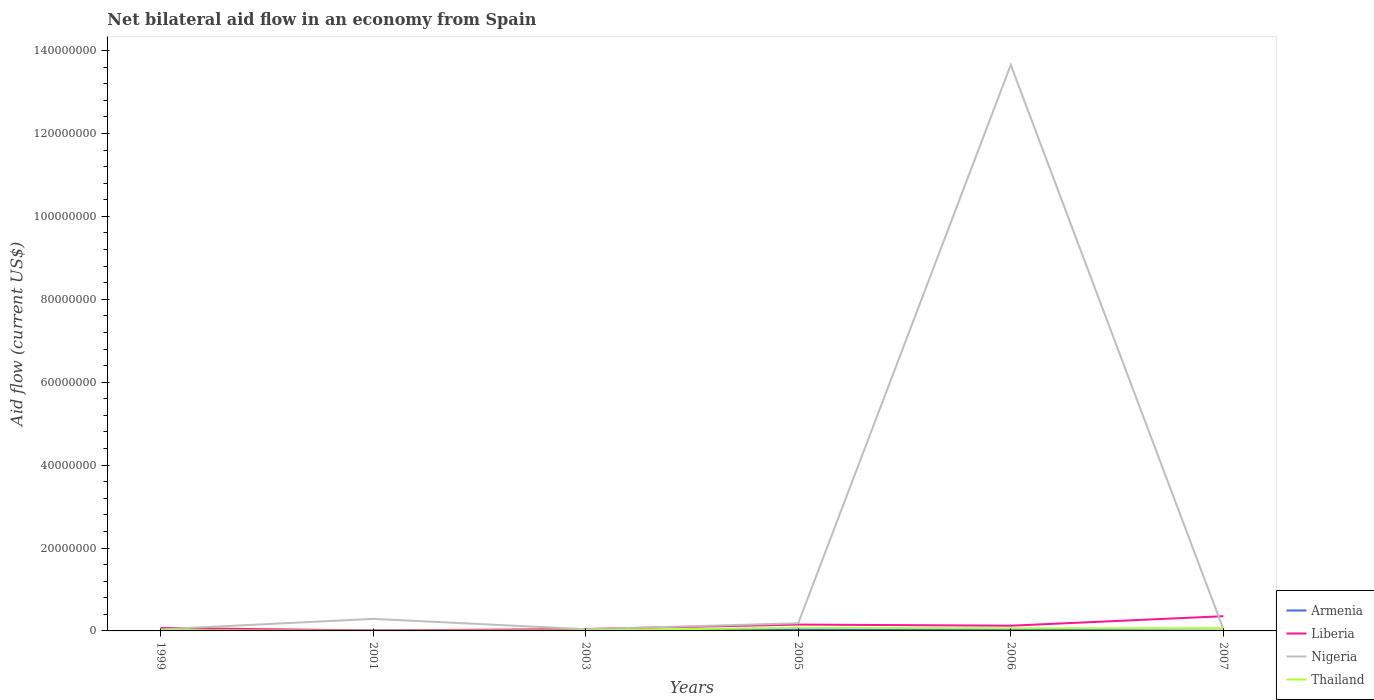Across all years, what is the maximum net bilateral aid flow in Thailand?
Offer a terse response. 5.00e+04. What is the total net bilateral aid flow in Armenia in the graph?
Your response must be concise. 3.00e+04. What is the difference between the highest and the second highest net bilateral aid flow in Thailand?
Your answer should be very brief. 7.10e+05. Is the net bilateral aid flow in Thailand strictly greater than the net bilateral aid flow in Armenia over the years?
Keep it short and to the point. No. What is the difference between two consecutive major ticks on the Y-axis?
Give a very brief answer. 2.00e+07. Does the graph contain grids?
Offer a terse response. No. Where does the legend appear in the graph?
Your answer should be compact. Bottom right. How are the legend labels stacked?
Your answer should be compact. Vertical. What is the title of the graph?
Offer a terse response. Net bilateral aid flow in an economy from Spain. Does "Somalia" appear as one of the legend labels in the graph?
Make the answer very short. No. What is the label or title of the X-axis?
Keep it short and to the point. Years. What is the label or title of the Y-axis?
Your response must be concise. Aid flow (current US$). What is the Aid flow (current US$) of Liberia in 1999?
Ensure brevity in your answer.  7.10e+05. What is the Aid flow (current US$) of Armenia in 2001?
Make the answer very short. 1.10e+05. What is the Aid flow (current US$) of Nigeria in 2001?
Offer a very short reply. 2.91e+06. What is the Aid flow (current US$) in Thailand in 2001?
Offer a terse response. 5.00e+04. What is the Aid flow (current US$) of Liberia in 2003?
Your answer should be compact. 4.60e+05. What is the Aid flow (current US$) in Nigeria in 2003?
Your answer should be very brief. 4.10e+05. What is the Aid flow (current US$) of Thailand in 2003?
Provide a succinct answer. 1.20e+05. What is the Aid flow (current US$) in Liberia in 2005?
Your answer should be compact. 1.53e+06. What is the Aid flow (current US$) in Nigeria in 2005?
Offer a terse response. 1.85e+06. What is the Aid flow (current US$) of Thailand in 2005?
Give a very brief answer. 7.60e+05. What is the Aid flow (current US$) in Liberia in 2006?
Your response must be concise. 1.26e+06. What is the Aid flow (current US$) in Nigeria in 2006?
Give a very brief answer. 1.37e+08. What is the Aid flow (current US$) in Thailand in 2006?
Your answer should be very brief. 6.20e+05. What is the Aid flow (current US$) in Armenia in 2007?
Your response must be concise. 5.00e+04. What is the Aid flow (current US$) in Liberia in 2007?
Offer a terse response. 3.55e+06. What is the Aid flow (current US$) in Nigeria in 2007?
Your answer should be very brief. 4.70e+05. What is the Aid flow (current US$) in Thailand in 2007?
Your answer should be very brief. 6.60e+05. Across all years, what is the maximum Aid flow (current US$) in Armenia?
Ensure brevity in your answer.  3.90e+05. Across all years, what is the maximum Aid flow (current US$) of Liberia?
Offer a terse response. 3.55e+06. Across all years, what is the maximum Aid flow (current US$) of Nigeria?
Your response must be concise. 1.37e+08. Across all years, what is the maximum Aid flow (current US$) of Thailand?
Your answer should be compact. 7.60e+05. Across all years, what is the minimum Aid flow (current US$) of Armenia?
Give a very brief answer. 5.00e+04. Across all years, what is the minimum Aid flow (current US$) of Liberia?
Your answer should be compact. 1.10e+05. Across all years, what is the minimum Aid flow (current US$) of Nigeria?
Provide a short and direct response. 3.80e+05. What is the total Aid flow (current US$) in Armenia in the graph?
Your response must be concise. 9.80e+05. What is the total Aid flow (current US$) in Liberia in the graph?
Your answer should be compact. 7.62e+06. What is the total Aid flow (current US$) of Nigeria in the graph?
Your answer should be compact. 1.43e+08. What is the total Aid flow (current US$) of Thailand in the graph?
Keep it short and to the point. 2.38e+06. What is the difference between the Aid flow (current US$) in Armenia in 1999 and that in 2001?
Offer a terse response. -5.00e+04. What is the difference between the Aid flow (current US$) of Nigeria in 1999 and that in 2001?
Give a very brief answer. -2.53e+06. What is the difference between the Aid flow (current US$) of Armenia in 1999 and that in 2003?
Keep it short and to the point. -2.00e+04. What is the difference between the Aid flow (current US$) of Liberia in 1999 and that in 2003?
Offer a very short reply. 2.50e+05. What is the difference between the Aid flow (current US$) of Thailand in 1999 and that in 2003?
Give a very brief answer. 5.00e+04. What is the difference between the Aid flow (current US$) in Armenia in 1999 and that in 2005?
Keep it short and to the point. -3.30e+05. What is the difference between the Aid flow (current US$) in Liberia in 1999 and that in 2005?
Provide a succinct answer. -8.20e+05. What is the difference between the Aid flow (current US$) in Nigeria in 1999 and that in 2005?
Give a very brief answer. -1.47e+06. What is the difference between the Aid flow (current US$) of Thailand in 1999 and that in 2005?
Ensure brevity in your answer.  -5.90e+05. What is the difference between the Aid flow (current US$) of Liberia in 1999 and that in 2006?
Offer a very short reply. -5.50e+05. What is the difference between the Aid flow (current US$) in Nigeria in 1999 and that in 2006?
Provide a succinct answer. -1.36e+08. What is the difference between the Aid flow (current US$) of Thailand in 1999 and that in 2006?
Ensure brevity in your answer.  -4.50e+05. What is the difference between the Aid flow (current US$) in Armenia in 1999 and that in 2007?
Keep it short and to the point. 10000. What is the difference between the Aid flow (current US$) of Liberia in 1999 and that in 2007?
Make the answer very short. -2.84e+06. What is the difference between the Aid flow (current US$) of Nigeria in 1999 and that in 2007?
Provide a succinct answer. -9.00e+04. What is the difference between the Aid flow (current US$) in Thailand in 1999 and that in 2007?
Keep it short and to the point. -4.90e+05. What is the difference between the Aid flow (current US$) of Armenia in 2001 and that in 2003?
Provide a short and direct response. 3.00e+04. What is the difference between the Aid flow (current US$) of Liberia in 2001 and that in 2003?
Make the answer very short. -3.50e+05. What is the difference between the Aid flow (current US$) of Nigeria in 2001 and that in 2003?
Keep it short and to the point. 2.50e+06. What is the difference between the Aid flow (current US$) of Armenia in 2001 and that in 2005?
Give a very brief answer. -2.80e+05. What is the difference between the Aid flow (current US$) in Liberia in 2001 and that in 2005?
Keep it short and to the point. -1.42e+06. What is the difference between the Aid flow (current US$) in Nigeria in 2001 and that in 2005?
Make the answer very short. 1.06e+06. What is the difference between the Aid flow (current US$) of Thailand in 2001 and that in 2005?
Provide a short and direct response. -7.10e+05. What is the difference between the Aid flow (current US$) of Armenia in 2001 and that in 2006?
Make the answer very short. -1.80e+05. What is the difference between the Aid flow (current US$) of Liberia in 2001 and that in 2006?
Ensure brevity in your answer.  -1.15e+06. What is the difference between the Aid flow (current US$) of Nigeria in 2001 and that in 2006?
Your response must be concise. -1.34e+08. What is the difference between the Aid flow (current US$) of Thailand in 2001 and that in 2006?
Your response must be concise. -5.70e+05. What is the difference between the Aid flow (current US$) in Armenia in 2001 and that in 2007?
Ensure brevity in your answer.  6.00e+04. What is the difference between the Aid flow (current US$) of Liberia in 2001 and that in 2007?
Provide a succinct answer. -3.44e+06. What is the difference between the Aid flow (current US$) of Nigeria in 2001 and that in 2007?
Provide a succinct answer. 2.44e+06. What is the difference between the Aid flow (current US$) of Thailand in 2001 and that in 2007?
Make the answer very short. -6.10e+05. What is the difference between the Aid flow (current US$) of Armenia in 2003 and that in 2005?
Offer a very short reply. -3.10e+05. What is the difference between the Aid flow (current US$) of Liberia in 2003 and that in 2005?
Your response must be concise. -1.07e+06. What is the difference between the Aid flow (current US$) of Nigeria in 2003 and that in 2005?
Provide a succinct answer. -1.44e+06. What is the difference between the Aid flow (current US$) of Thailand in 2003 and that in 2005?
Offer a terse response. -6.40e+05. What is the difference between the Aid flow (current US$) of Liberia in 2003 and that in 2006?
Offer a very short reply. -8.00e+05. What is the difference between the Aid flow (current US$) in Nigeria in 2003 and that in 2006?
Offer a very short reply. -1.36e+08. What is the difference between the Aid flow (current US$) of Thailand in 2003 and that in 2006?
Your answer should be compact. -5.00e+05. What is the difference between the Aid flow (current US$) of Liberia in 2003 and that in 2007?
Keep it short and to the point. -3.09e+06. What is the difference between the Aid flow (current US$) of Nigeria in 2003 and that in 2007?
Your answer should be compact. -6.00e+04. What is the difference between the Aid flow (current US$) of Thailand in 2003 and that in 2007?
Your answer should be compact. -5.40e+05. What is the difference between the Aid flow (current US$) in Liberia in 2005 and that in 2006?
Your response must be concise. 2.70e+05. What is the difference between the Aid flow (current US$) of Nigeria in 2005 and that in 2006?
Your answer should be compact. -1.35e+08. What is the difference between the Aid flow (current US$) in Thailand in 2005 and that in 2006?
Your answer should be very brief. 1.40e+05. What is the difference between the Aid flow (current US$) of Armenia in 2005 and that in 2007?
Give a very brief answer. 3.40e+05. What is the difference between the Aid flow (current US$) of Liberia in 2005 and that in 2007?
Ensure brevity in your answer.  -2.02e+06. What is the difference between the Aid flow (current US$) in Nigeria in 2005 and that in 2007?
Give a very brief answer. 1.38e+06. What is the difference between the Aid flow (current US$) in Liberia in 2006 and that in 2007?
Offer a terse response. -2.29e+06. What is the difference between the Aid flow (current US$) in Nigeria in 2006 and that in 2007?
Make the answer very short. 1.36e+08. What is the difference between the Aid flow (current US$) of Thailand in 2006 and that in 2007?
Make the answer very short. -4.00e+04. What is the difference between the Aid flow (current US$) of Armenia in 1999 and the Aid flow (current US$) of Nigeria in 2001?
Provide a short and direct response. -2.85e+06. What is the difference between the Aid flow (current US$) of Armenia in 1999 and the Aid flow (current US$) of Thailand in 2001?
Your response must be concise. 10000. What is the difference between the Aid flow (current US$) of Liberia in 1999 and the Aid flow (current US$) of Nigeria in 2001?
Make the answer very short. -2.20e+06. What is the difference between the Aid flow (current US$) in Armenia in 1999 and the Aid flow (current US$) in Liberia in 2003?
Your answer should be compact. -4.00e+05. What is the difference between the Aid flow (current US$) of Armenia in 1999 and the Aid flow (current US$) of Nigeria in 2003?
Provide a succinct answer. -3.50e+05. What is the difference between the Aid flow (current US$) in Armenia in 1999 and the Aid flow (current US$) in Thailand in 2003?
Provide a short and direct response. -6.00e+04. What is the difference between the Aid flow (current US$) of Liberia in 1999 and the Aid flow (current US$) of Thailand in 2003?
Your answer should be very brief. 5.90e+05. What is the difference between the Aid flow (current US$) of Nigeria in 1999 and the Aid flow (current US$) of Thailand in 2003?
Provide a succinct answer. 2.60e+05. What is the difference between the Aid flow (current US$) of Armenia in 1999 and the Aid flow (current US$) of Liberia in 2005?
Provide a short and direct response. -1.47e+06. What is the difference between the Aid flow (current US$) of Armenia in 1999 and the Aid flow (current US$) of Nigeria in 2005?
Provide a succinct answer. -1.79e+06. What is the difference between the Aid flow (current US$) of Armenia in 1999 and the Aid flow (current US$) of Thailand in 2005?
Offer a very short reply. -7.00e+05. What is the difference between the Aid flow (current US$) in Liberia in 1999 and the Aid flow (current US$) in Nigeria in 2005?
Your answer should be compact. -1.14e+06. What is the difference between the Aid flow (current US$) in Nigeria in 1999 and the Aid flow (current US$) in Thailand in 2005?
Offer a terse response. -3.80e+05. What is the difference between the Aid flow (current US$) in Armenia in 1999 and the Aid flow (current US$) in Liberia in 2006?
Give a very brief answer. -1.20e+06. What is the difference between the Aid flow (current US$) in Armenia in 1999 and the Aid flow (current US$) in Nigeria in 2006?
Give a very brief answer. -1.36e+08. What is the difference between the Aid flow (current US$) of Armenia in 1999 and the Aid flow (current US$) of Thailand in 2006?
Make the answer very short. -5.60e+05. What is the difference between the Aid flow (current US$) in Liberia in 1999 and the Aid flow (current US$) in Nigeria in 2006?
Your answer should be compact. -1.36e+08. What is the difference between the Aid flow (current US$) of Armenia in 1999 and the Aid flow (current US$) of Liberia in 2007?
Offer a very short reply. -3.49e+06. What is the difference between the Aid flow (current US$) of Armenia in 1999 and the Aid flow (current US$) of Nigeria in 2007?
Make the answer very short. -4.10e+05. What is the difference between the Aid flow (current US$) of Armenia in 1999 and the Aid flow (current US$) of Thailand in 2007?
Ensure brevity in your answer.  -6.00e+05. What is the difference between the Aid flow (current US$) in Liberia in 1999 and the Aid flow (current US$) in Nigeria in 2007?
Offer a very short reply. 2.40e+05. What is the difference between the Aid flow (current US$) of Liberia in 1999 and the Aid flow (current US$) of Thailand in 2007?
Your response must be concise. 5.00e+04. What is the difference between the Aid flow (current US$) of Nigeria in 1999 and the Aid flow (current US$) of Thailand in 2007?
Your answer should be compact. -2.80e+05. What is the difference between the Aid flow (current US$) in Armenia in 2001 and the Aid flow (current US$) in Liberia in 2003?
Your response must be concise. -3.50e+05. What is the difference between the Aid flow (current US$) in Armenia in 2001 and the Aid flow (current US$) in Thailand in 2003?
Give a very brief answer. -10000. What is the difference between the Aid flow (current US$) of Liberia in 2001 and the Aid flow (current US$) of Nigeria in 2003?
Your response must be concise. -3.00e+05. What is the difference between the Aid flow (current US$) of Nigeria in 2001 and the Aid flow (current US$) of Thailand in 2003?
Offer a terse response. 2.79e+06. What is the difference between the Aid flow (current US$) of Armenia in 2001 and the Aid flow (current US$) of Liberia in 2005?
Your answer should be compact. -1.42e+06. What is the difference between the Aid flow (current US$) of Armenia in 2001 and the Aid flow (current US$) of Nigeria in 2005?
Provide a short and direct response. -1.74e+06. What is the difference between the Aid flow (current US$) in Armenia in 2001 and the Aid flow (current US$) in Thailand in 2005?
Your answer should be compact. -6.50e+05. What is the difference between the Aid flow (current US$) of Liberia in 2001 and the Aid flow (current US$) of Nigeria in 2005?
Provide a short and direct response. -1.74e+06. What is the difference between the Aid flow (current US$) of Liberia in 2001 and the Aid flow (current US$) of Thailand in 2005?
Your response must be concise. -6.50e+05. What is the difference between the Aid flow (current US$) of Nigeria in 2001 and the Aid flow (current US$) of Thailand in 2005?
Give a very brief answer. 2.15e+06. What is the difference between the Aid flow (current US$) of Armenia in 2001 and the Aid flow (current US$) of Liberia in 2006?
Provide a succinct answer. -1.15e+06. What is the difference between the Aid flow (current US$) in Armenia in 2001 and the Aid flow (current US$) in Nigeria in 2006?
Ensure brevity in your answer.  -1.36e+08. What is the difference between the Aid flow (current US$) in Armenia in 2001 and the Aid flow (current US$) in Thailand in 2006?
Keep it short and to the point. -5.10e+05. What is the difference between the Aid flow (current US$) of Liberia in 2001 and the Aid flow (current US$) of Nigeria in 2006?
Ensure brevity in your answer.  -1.36e+08. What is the difference between the Aid flow (current US$) in Liberia in 2001 and the Aid flow (current US$) in Thailand in 2006?
Give a very brief answer. -5.10e+05. What is the difference between the Aid flow (current US$) of Nigeria in 2001 and the Aid flow (current US$) of Thailand in 2006?
Keep it short and to the point. 2.29e+06. What is the difference between the Aid flow (current US$) of Armenia in 2001 and the Aid flow (current US$) of Liberia in 2007?
Give a very brief answer. -3.44e+06. What is the difference between the Aid flow (current US$) of Armenia in 2001 and the Aid flow (current US$) of Nigeria in 2007?
Give a very brief answer. -3.60e+05. What is the difference between the Aid flow (current US$) in Armenia in 2001 and the Aid flow (current US$) in Thailand in 2007?
Offer a very short reply. -5.50e+05. What is the difference between the Aid flow (current US$) in Liberia in 2001 and the Aid flow (current US$) in Nigeria in 2007?
Provide a short and direct response. -3.60e+05. What is the difference between the Aid flow (current US$) in Liberia in 2001 and the Aid flow (current US$) in Thailand in 2007?
Keep it short and to the point. -5.50e+05. What is the difference between the Aid flow (current US$) in Nigeria in 2001 and the Aid flow (current US$) in Thailand in 2007?
Ensure brevity in your answer.  2.25e+06. What is the difference between the Aid flow (current US$) of Armenia in 2003 and the Aid flow (current US$) of Liberia in 2005?
Your answer should be compact. -1.45e+06. What is the difference between the Aid flow (current US$) in Armenia in 2003 and the Aid flow (current US$) in Nigeria in 2005?
Your answer should be very brief. -1.77e+06. What is the difference between the Aid flow (current US$) in Armenia in 2003 and the Aid flow (current US$) in Thailand in 2005?
Offer a very short reply. -6.80e+05. What is the difference between the Aid flow (current US$) of Liberia in 2003 and the Aid flow (current US$) of Nigeria in 2005?
Offer a terse response. -1.39e+06. What is the difference between the Aid flow (current US$) of Nigeria in 2003 and the Aid flow (current US$) of Thailand in 2005?
Your answer should be compact. -3.50e+05. What is the difference between the Aid flow (current US$) of Armenia in 2003 and the Aid flow (current US$) of Liberia in 2006?
Make the answer very short. -1.18e+06. What is the difference between the Aid flow (current US$) in Armenia in 2003 and the Aid flow (current US$) in Nigeria in 2006?
Ensure brevity in your answer.  -1.36e+08. What is the difference between the Aid flow (current US$) of Armenia in 2003 and the Aid flow (current US$) of Thailand in 2006?
Give a very brief answer. -5.40e+05. What is the difference between the Aid flow (current US$) in Liberia in 2003 and the Aid flow (current US$) in Nigeria in 2006?
Offer a very short reply. -1.36e+08. What is the difference between the Aid flow (current US$) of Armenia in 2003 and the Aid flow (current US$) of Liberia in 2007?
Provide a short and direct response. -3.47e+06. What is the difference between the Aid flow (current US$) of Armenia in 2003 and the Aid flow (current US$) of Nigeria in 2007?
Offer a very short reply. -3.90e+05. What is the difference between the Aid flow (current US$) in Armenia in 2003 and the Aid flow (current US$) in Thailand in 2007?
Your response must be concise. -5.80e+05. What is the difference between the Aid flow (current US$) in Liberia in 2003 and the Aid flow (current US$) in Thailand in 2007?
Keep it short and to the point. -2.00e+05. What is the difference between the Aid flow (current US$) of Armenia in 2005 and the Aid flow (current US$) of Liberia in 2006?
Offer a very short reply. -8.70e+05. What is the difference between the Aid flow (current US$) of Armenia in 2005 and the Aid flow (current US$) of Nigeria in 2006?
Offer a terse response. -1.36e+08. What is the difference between the Aid flow (current US$) in Armenia in 2005 and the Aid flow (current US$) in Thailand in 2006?
Ensure brevity in your answer.  -2.30e+05. What is the difference between the Aid flow (current US$) in Liberia in 2005 and the Aid flow (current US$) in Nigeria in 2006?
Your answer should be very brief. -1.35e+08. What is the difference between the Aid flow (current US$) of Liberia in 2005 and the Aid flow (current US$) of Thailand in 2006?
Ensure brevity in your answer.  9.10e+05. What is the difference between the Aid flow (current US$) of Nigeria in 2005 and the Aid flow (current US$) of Thailand in 2006?
Ensure brevity in your answer.  1.23e+06. What is the difference between the Aid flow (current US$) of Armenia in 2005 and the Aid flow (current US$) of Liberia in 2007?
Offer a very short reply. -3.16e+06. What is the difference between the Aid flow (current US$) of Armenia in 2005 and the Aid flow (current US$) of Thailand in 2007?
Offer a very short reply. -2.70e+05. What is the difference between the Aid flow (current US$) in Liberia in 2005 and the Aid flow (current US$) in Nigeria in 2007?
Make the answer very short. 1.06e+06. What is the difference between the Aid flow (current US$) of Liberia in 2005 and the Aid flow (current US$) of Thailand in 2007?
Offer a terse response. 8.70e+05. What is the difference between the Aid flow (current US$) of Nigeria in 2005 and the Aid flow (current US$) of Thailand in 2007?
Make the answer very short. 1.19e+06. What is the difference between the Aid flow (current US$) of Armenia in 2006 and the Aid flow (current US$) of Liberia in 2007?
Your answer should be very brief. -3.26e+06. What is the difference between the Aid flow (current US$) in Armenia in 2006 and the Aid flow (current US$) in Thailand in 2007?
Your answer should be very brief. -3.70e+05. What is the difference between the Aid flow (current US$) in Liberia in 2006 and the Aid flow (current US$) in Nigeria in 2007?
Provide a succinct answer. 7.90e+05. What is the difference between the Aid flow (current US$) of Nigeria in 2006 and the Aid flow (current US$) of Thailand in 2007?
Provide a succinct answer. 1.36e+08. What is the average Aid flow (current US$) of Armenia per year?
Make the answer very short. 1.63e+05. What is the average Aid flow (current US$) in Liberia per year?
Ensure brevity in your answer.  1.27e+06. What is the average Aid flow (current US$) in Nigeria per year?
Give a very brief answer. 2.38e+07. What is the average Aid flow (current US$) of Thailand per year?
Your answer should be compact. 3.97e+05. In the year 1999, what is the difference between the Aid flow (current US$) of Armenia and Aid flow (current US$) of Liberia?
Provide a succinct answer. -6.50e+05. In the year 1999, what is the difference between the Aid flow (current US$) of Armenia and Aid flow (current US$) of Nigeria?
Ensure brevity in your answer.  -3.20e+05. In the year 1999, what is the difference between the Aid flow (current US$) of Liberia and Aid flow (current US$) of Thailand?
Give a very brief answer. 5.40e+05. In the year 1999, what is the difference between the Aid flow (current US$) of Nigeria and Aid flow (current US$) of Thailand?
Your answer should be compact. 2.10e+05. In the year 2001, what is the difference between the Aid flow (current US$) of Armenia and Aid flow (current US$) of Nigeria?
Make the answer very short. -2.80e+06. In the year 2001, what is the difference between the Aid flow (current US$) of Liberia and Aid flow (current US$) of Nigeria?
Give a very brief answer. -2.80e+06. In the year 2001, what is the difference between the Aid flow (current US$) of Liberia and Aid flow (current US$) of Thailand?
Make the answer very short. 6.00e+04. In the year 2001, what is the difference between the Aid flow (current US$) of Nigeria and Aid flow (current US$) of Thailand?
Your answer should be very brief. 2.86e+06. In the year 2003, what is the difference between the Aid flow (current US$) of Armenia and Aid flow (current US$) of Liberia?
Provide a short and direct response. -3.80e+05. In the year 2003, what is the difference between the Aid flow (current US$) in Armenia and Aid flow (current US$) in Nigeria?
Offer a terse response. -3.30e+05. In the year 2003, what is the difference between the Aid flow (current US$) of Armenia and Aid flow (current US$) of Thailand?
Provide a succinct answer. -4.00e+04. In the year 2003, what is the difference between the Aid flow (current US$) in Liberia and Aid flow (current US$) in Thailand?
Offer a very short reply. 3.40e+05. In the year 2005, what is the difference between the Aid flow (current US$) in Armenia and Aid flow (current US$) in Liberia?
Offer a very short reply. -1.14e+06. In the year 2005, what is the difference between the Aid flow (current US$) of Armenia and Aid flow (current US$) of Nigeria?
Offer a terse response. -1.46e+06. In the year 2005, what is the difference between the Aid flow (current US$) in Armenia and Aid flow (current US$) in Thailand?
Ensure brevity in your answer.  -3.70e+05. In the year 2005, what is the difference between the Aid flow (current US$) of Liberia and Aid flow (current US$) of Nigeria?
Your answer should be very brief. -3.20e+05. In the year 2005, what is the difference between the Aid flow (current US$) of Liberia and Aid flow (current US$) of Thailand?
Offer a terse response. 7.70e+05. In the year 2005, what is the difference between the Aid flow (current US$) in Nigeria and Aid flow (current US$) in Thailand?
Offer a very short reply. 1.09e+06. In the year 2006, what is the difference between the Aid flow (current US$) in Armenia and Aid flow (current US$) in Liberia?
Keep it short and to the point. -9.70e+05. In the year 2006, what is the difference between the Aid flow (current US$) of Armenia and Aid flow (current US$) of Nigeria?
Offer a very short reply. -1.36e+08. In the year 2006, what is the difference between the Aid flow (current US$) in Armenia and Aid flow (current US$) in Thailand?
Make the answer very short. -3.30e+05. In the year 2006, what is the difference between the Aid flow (current US$) of Liberia and Aid flow (current US$) of Nigeria?
Your answer should be compact. -1.35e+08. In the year 2006, what is the difference between the Aid flow (current US$) in Liberia and Aid flow (current US$) in Thailand?
Make the answer very short. 6.40e+05. In the year 2006, what is the difference between the Aid flow (current US$) of Nigeria and Aid flow (current US$) of Thailand?
Offer a terse response. 1.36e+08. In the year 2007, what is the difference between the Aid flow (current US$) in Armenia and Aid flow (current US$) in Liberia?
Keep it short and to the point. -3.50e+06. In the year 2007, what is the difference between the Aid flow (current US$) of Armenia and Aid flow (current US$) of Nigeria?
Offer a very short reply. -4.20e+05. In the year 2007, what is the difference between the Aid flow (current US$) in Armenia and Aid flow (current US$) in Thailand?
Your response must be concise. -6.10e+05. In the year 2007, what is the difference between the Aid flow (current US$) of Liberia and Aid flow (current US$) of Nigeria?
Give a very brief answer. 3.08e+06. In the year 2007, what is the difference between the Aid flow (current US$) in Liberia and Aid flow (current US$) in Thailand?
Offer a terse response. 2.89e+06. In the year 2007, what is the difference between the Aid flow (current US$) in Nigeria and Aid flow (current US$) in Thailand?
Provide a short and direct response. -1.90e+05. What is the ratio of the Aid flow (current US$) of Armenia in 1999 to that in 2001?
Offer a very short reply. 0.55. What is the ratio of the Aid flow (current US$) of Liberia in 1999 to that in 2001?
Offer a very short reply. 6.45. What is the ratio of the Aid flow (current US$) of Nigeria in 1999 to that in 2001?
Give a very brief answer. 0.13. What is the ratio of the Aid flow (current US$) of Armenia in 1999 to that in 2003?
Your response must be concise. 0.75. What is the ratio of the Aid flow (current US$) of Liberia in 1999 to that in 2003?
Your answer should be compact. 1.54. What is the ratio of the Aid flow (current US$) in Nigeria in 1999 to that in 2003?
Your answer should be compact. 0.93. What is the ratio of the Aid flow (current US$) of Thailand in 1999 to that in 2003?
Provide a succinct answer. 1.42. What is the ratio of the Aid flow (current US$) of Armenia in 1999 to that in 2005?
Your answer should be compact. 0.15. What is the ratio of the Aid flow (current US$) in Liberia in 1999 to that in 2005?
Keep it short and to the point. 0.46. What is the ratio of the Aid flow (current US$) in Nigeria in 1999 to that in 2005?
Offer a terse response. 0.21. What is the ratio of the Aid flow (current US$) of Thailand in 1999 to that in 2005?
Keep it short and to the point. 0.22. What is the ratio of the Aid flow (current US$) in Armenia in 1999 to that in 2006?
Offer a terse response. 0.21. What is the ratio of the Aid flow (current US$) of Liberia in 1999 to that in 2006?
Offer a terse response. 0.56. What is the ratio of the Aid flow (current US$) of Nigeria in 1999 to that in 2006?
Ensure brevity in your answer.  0. What is the ratio of the Aid flow (current US$) in Thailand in 1999 to that in 2006?
Offer a very short reply. 0.27. What is the ratio of the Aid flow (current US$) of Liberia in 1999 to that in 2007?
Offer a terse response. 0.2. What is the ratio of the Aid flow (current US$) of Nigeria in 1999 to that in 2007?
Your answer should be very brief. 0.81. What is the ratio of the Aid flow (current US$) of Thailand in 1999 to that in 2007?
Your answer should be compact. 0.26. What is the ratio of the Aid flow (current US$) in Armenia in 2001 to that in 2003?
Provide a short and direct response. 1.38. What is the ratio of the Aid flow (current US$) of Liberia in 2001 to that in 2003?
Give a very brief answer. 0.24. What is the ratio of the Aid flow (current US$) in Nigeria in 2001 to that in 2003?
Offer a very short reply. 7.1. What is the ratio of the Aid flow (current US$) in Thailand in 2001 to that in 2003?
Provide a succinct answer. 0.42. What is the ratio of the Aid flow (current US$) of Armenia in 2001 to that in 2005?
Your answer should be compact. 0.28. What is the ratio of the Aid flow (current US$) of Liberia in 2001 to that in 2005?
Offer a very short reply. 0.07. What is the ratio of the Aid flow (current US$) of Nigeria in 2001 to that in 2005?
Ensure brevity in your answer.  1.57. What is the ratio of the Aid flow (current US$) in Thailand in 2001 to that in 2005?
Offer a terse response. 0.07. What is the ratio of the Aid flow (current US$) of Armenia in 2001 to that in 2006?
Give a very brief answer. 0.38. What is the ratio of the Aid flow (current US$) in Liberia in 2001 to that in 2006?
Keep it short and to the point. 0.09. What is the ratio of the Aid flow (current US$) in Nigeria in 2001 to that in 2006?
Ensure brevity in your answer.  0.02. What is the ratio of the Aid flow (current US$) in Thailand in 2001 to that in 2006?
Your answer should be compact. 0.08. What is the ratio of the Aid flow (current US$) of Armenia in 2001 to that in 2007?
Provide a succinct answer. 2.2. What is the ratio of the Aid flow (current US$) of Liberia in 2001 to that in 2007?
Your answer should be very brief. 0.03. What is the ratio of the Aid flow (current US$) of Nigeria in 2001 to that in 2007?
Give a very brief answer. 6.19. What is the ratio of the Aid flow (current US$) of Thailand in 2001 to that in 2007?
Your answer should be compact. 0.08. What is the ratio of the Aid flow (current US$) of Armenia in 2003 to that in 2005?
Keep it short and to the point. 0.21. What is the ratio of the Aid flow (current US$) in Liberia in 2003 to that in 2005?
Keep it short and to the point. 0.3. What is the ratio of the Aid flow (current US$) of Nigeria in 2003 to that in 2005?
Offer a very short reply. 0.22. What is the ratio of the Aid flow (current US$) in Thailand in 2003 to that in 2005?
Give a very brief answer. 0.16. What is the ratio of the Aid flow (current US$) of Armenia in 2003 to that in 2006?
Make the answer very short. 0.28. What is the ratio of the Aid flow (current US$) of Liberia in 2003 to that in 2006?
Your answer should be compact. 0.37. What is the ratio of the Aid flow (current US$) of Nigeria in 2003 to that in 2006?
Your answer should be very brief. 0. What is the ratio of the Aid flow (current US$) in Thailand in 2003 to that in 2006?
Your answer should be very brief. 0.19. What is the ratio of the Aid flow (current US$) in Armenia in 2003 to that in 2007?
Keep it short and to the point. 1.6. What is the ratio of the Aid flow (current US$) of Liberia in 2003 to that in 2007?
Give a very brief answer. 0.13. What is the ratio of the Aid flow (current US$) of Nigeria in 2003 to that in 2007?
Your answer should be very brief. 0.87. What is the ratio of the Aid flow (current US$) in Thailand in 2003 to that in 2007?
Provide a short and direct response. 0.18. What is the ratio of the Aid flow (current US$) in Armenia in 2005 to that in 2006?
Provide a short and direct response. 1.34. What is the ratio of the Aid flow (current US$) in Liberia in 2005 to that in 2006?
Your answer should be compact. 1.21. What is the ratio of the Aid flow (current US$) of Nigeria in 2005 to that in 2006?
Ensure brevity in your answer.  0.01. What is the ratio of the Aid flow (current US$) in Thailand in 2005 to that in 2006?
Your response must be concise. 1.23. What is the ratio of the Aid flow (current US$) in Armenia in 2005 to that in 2007?
Your answer should be very brief. 7.8. What is the ratio of the Aid flow (current US$) in Liberia in 2005 to that in 2007?
Offer a terse response. 0.43. What is the ratio of the Aid flow (current US$) in Nigeria in 2005 to that in 2007?
Your answer should be very brief. 3.94. What is the ratio of the Aid flow (current US$) in Thailand in 2005 to that in 2007?
Give a very brief answer. 1.15. What is the ratio of the Aid flow (current US$) of Liberia in 2006 to that in 2007?
Provide a short and direct response. 0.35. What is the ratio of the Aid flow (current US$) of Nigeria in 2006 to that in 2007?
Your response must be concise. 290.51. What is the ratio of the Aid flow (current US$) in Thailand in 2006 to that in 2007?
Provide a succinct answer. 0.94. What is the difference between the highest and the second highest Aid flow (current US$) of Armenia?
Keep it short and to the point. 1.00e+05. What is the difference between the highest and the second highest Aid flow (current US$) in Liberia?
Your answer should be very brief. 2.02e+06. What is the difference between the highest and the second highest Aid flow (current US$) in Nigeria?
Give a very brief answer. 1.34e+08. What is the difference between the highest and the lowest Aid flow (current US$) of Liberia?
Give a very brief answer. 3.44e+06. What is the difference between the highest and the lowest Aid flow (current US$) in Nigeria?
Give a very brief answer. 1.36e+08. What is the difference between the highest and the lowest Aid flow (current US$) of Thailand?
Keep it short and to the point. 7.10e+05. 